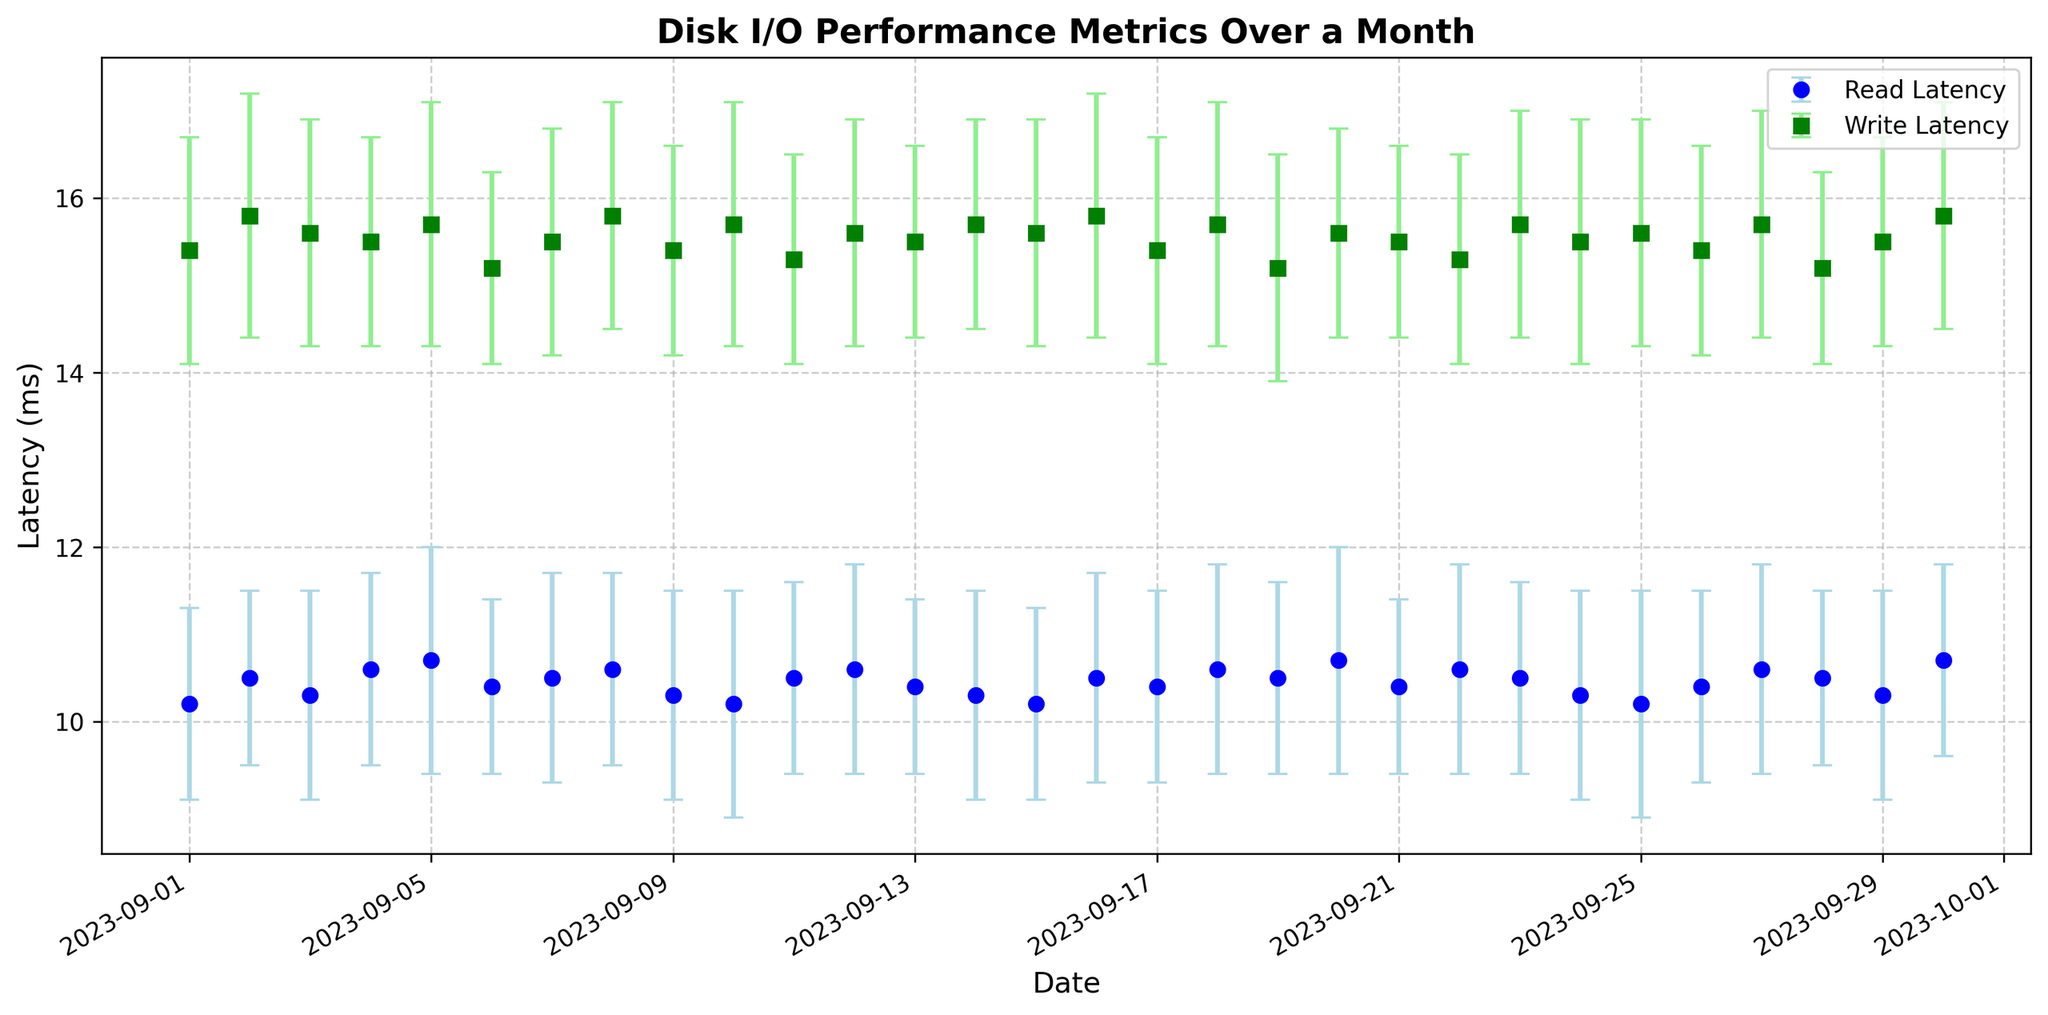What's the date with the highest standard deviation for read latency? To find the date with the highest standard deviation for read latency, we look at the error bars representing the standard deviation for read latency (blue). The date with the highest error bar for read latency is 2023-09-05.
Answer: 2023-09-05 On average, which latency (read or write) has lower values over the entire month? We compare the average values of the read and write latencies. Visually, the read latency values (blue) seem generally lower than the write latency values (green) over the period displayed.
Answer: Read latency What's the date where the read latency mean is equal to the write latency mean? We search for any intersection points where the blue (read latency) and green (write latency) markers are exactly at the same level. There’s no such point where the means are equal.
Answer: None What is the range of values for the write latency mean over the month? To calculate the range, find the maximum and minimum write latency mean values from the green markers. The maximum is 15.8 ms (on 2023-09-08 and 2023-09-30), and the minimum is 15.2 ms (on 2023-09-06 and 2023-09-19). Therefore, the range is 15.8 - 15.2 = 0.6 ms.
Answer: 0.6 ms Which day shows the highest mean value for write latency? By looking at the green markers, we identify 2023-09-08 and 2023-09-30 having the highest write mean latency value of 15.8 ms.
Answer: 2023-09-08 and 2023-09-30 On 2023-09-11, how does the read latency compare to the write latency? We locate the data point for 2023-09-11 and observe the read latency marker (blue) and the write latency marker (green). The read latency mean is 10.5 ms, and the write latency mean is 15.3 ms, so read latency is lower.
Answer: Read latency is lower Which date had the smallest error bar for write latency, indicating the lowest variance? We look at the error bars for write latency (green) and identify the smallest one. The smallest error bar is found on 2023-09-06, with a standard deviation of 1.1 ms.
Answer: 2023-09-06 What is the overall trend in read latency over the month? Observing the blue markers and their overall direction, read latencies stay relatively consistent with minor fluctuations, and no strong increasing or decreasing trend is evident.
Answer: Relatively consistent On 2023-09-25, are the error ranges for read and write latencies overlapping? We check if the error bars for read (blue) and write (green) latencies on 2023-09-25 intersect. The range for read latency is 10.2 ± 1.3 ms (8.9 to 11.5 ms), and for write latency, it’s 15.6 ± 1.3 ms (14.3 to 16.9 ms), which do not overlap.
Answer: No What is the largest difference between mean read and write latencies on any single day? We find the day with the biggest disparity between read and write latencies by calculating the difference for each day. The largest difference is on 2023-09-01 with write latency 15.4 ms and read latency 10.2 ms, giving 15.4 - 10.2 = 5.2 ms.
Answer: 5.2 ms 